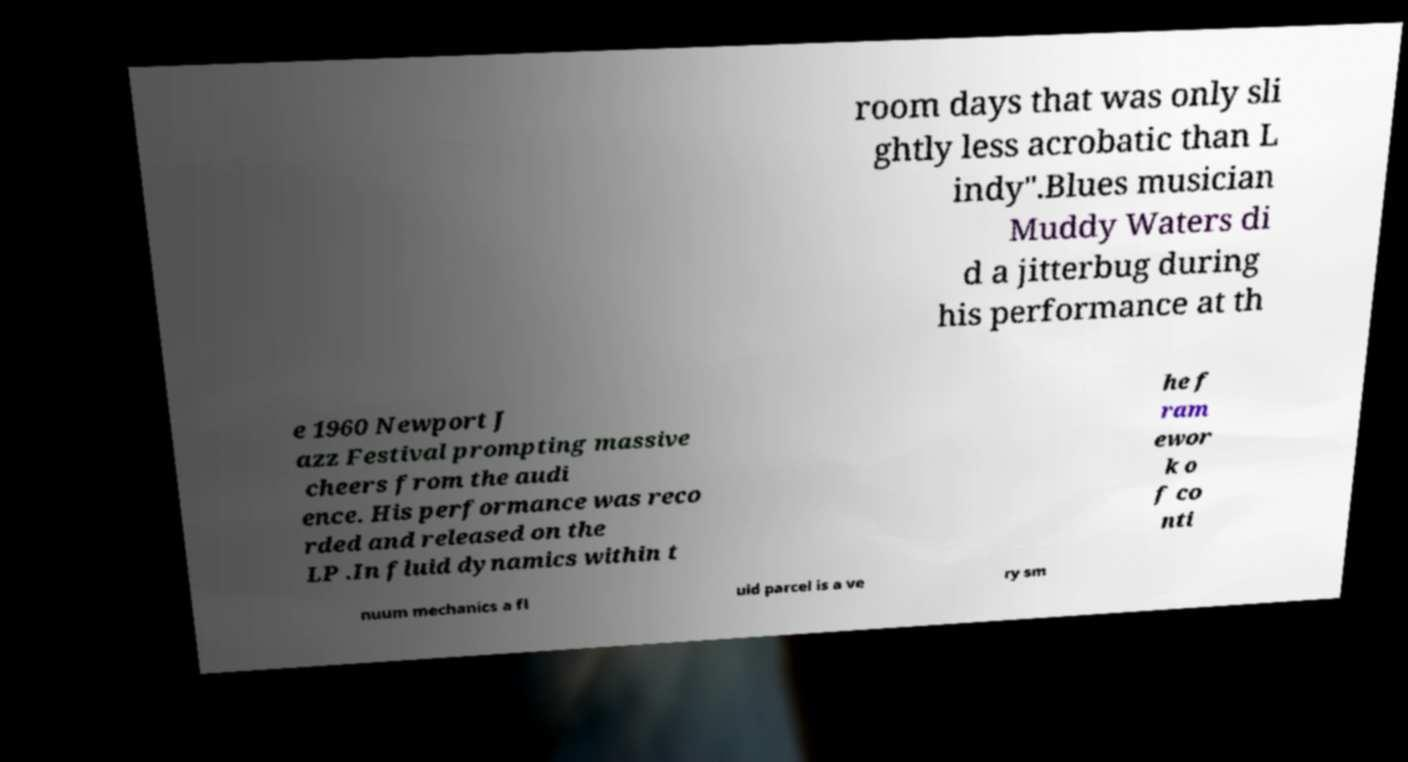There's text embedded in this image that I need extracted. Can you transcribe it verbatim? room days that was only sli ghtly less acrobatic than L indy".Blues musician Muddy Waters di d a jitterbug during his performance at th e 1960 Newport J azz Festival prompting massive cheers from the audi ence. His performance was reco rded and released on the LP .In fluid dynamics within t he f ram ewor k o f co nti nuum mechanics a fl uid parcel is a ve ry sm 